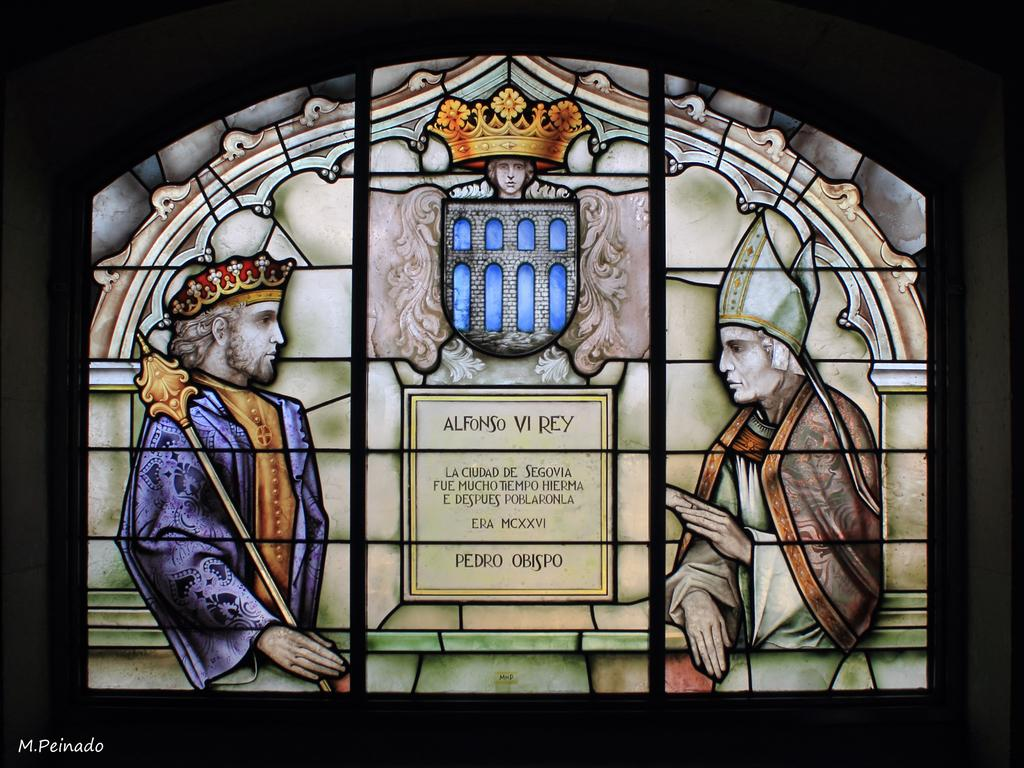<image>
Give a short and clear explanation of the subsequent image. A stained glass window has two men facing one another and it says Alfonso Vi Rey between them. 